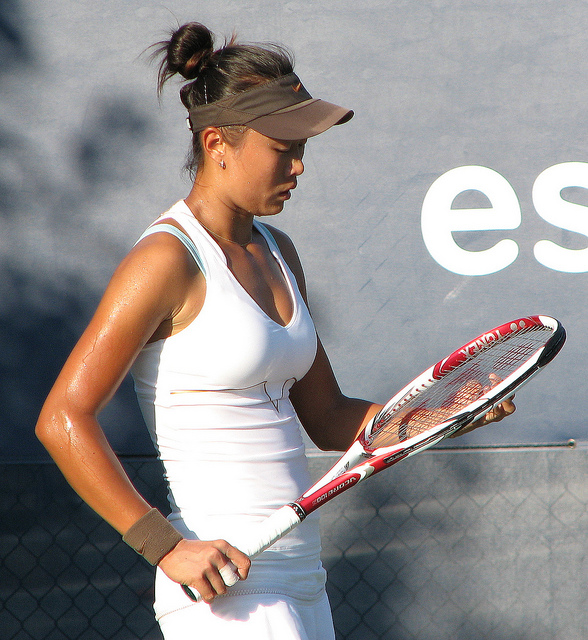Please transcribe the text information in this image. es 